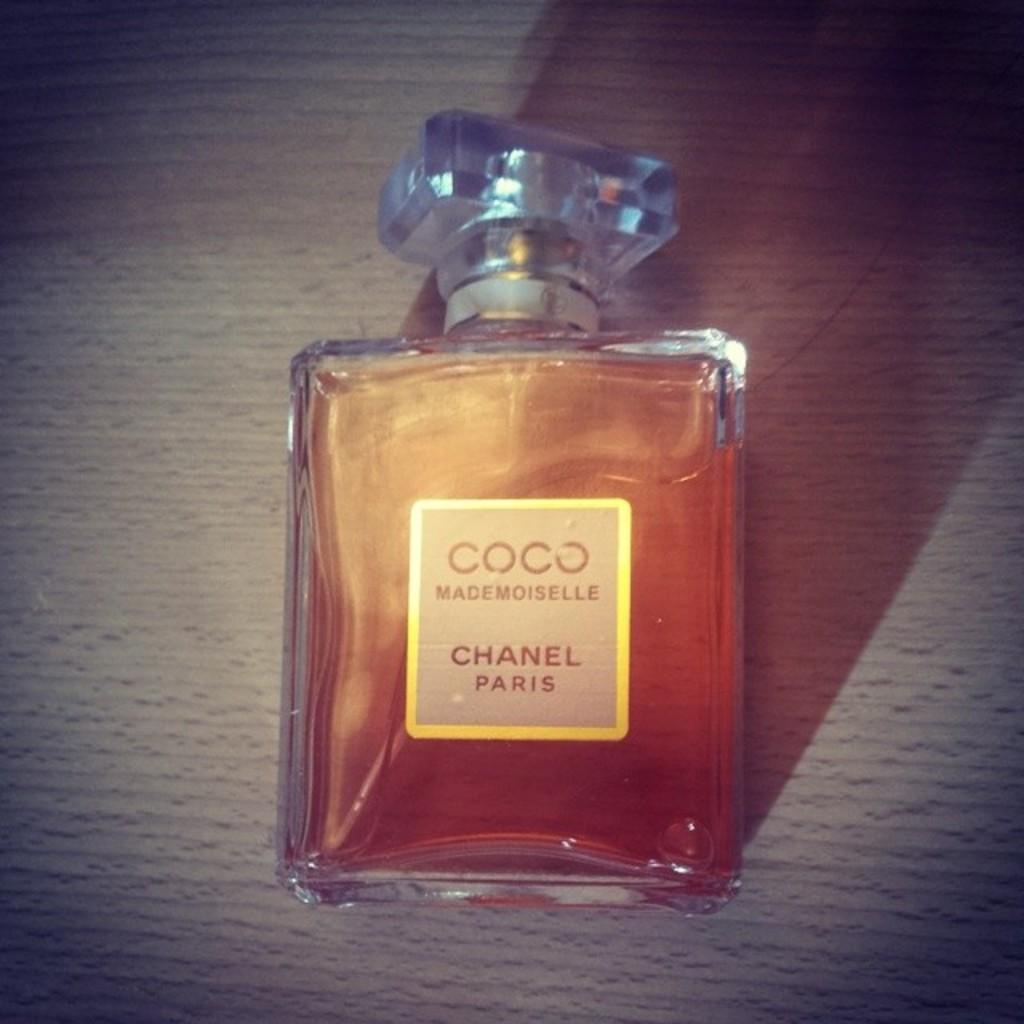<image>
Share a concise interpretation of the image provided. a bottle of Coco Mademoiselle perfume by Chanel 